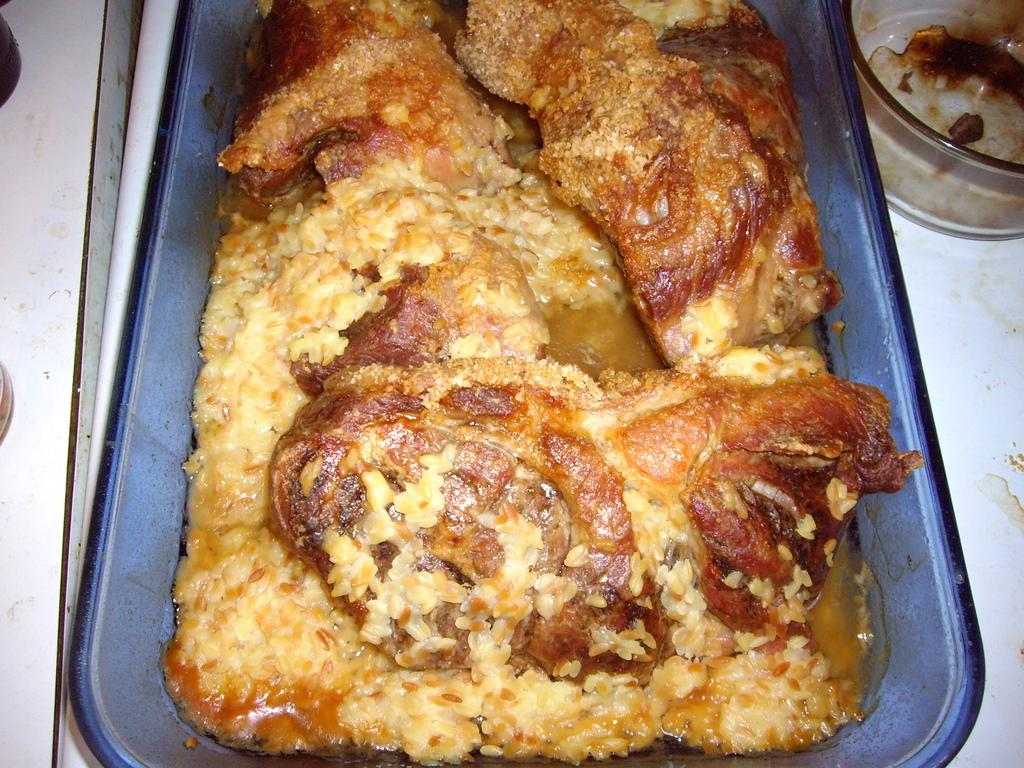What is on the tray in the image? There is a food item on the tray in the image. What is the shape of the container on the surface in the image? There is a glass bowl on a surface in the image. What is inside the glass bowl in the image? There is an item inside the bowl in the image. What type of authority is depicted in the image? There is no authority figure present in the image. What station is the honey being sold at in the image? There is no honey or station present in the image. 